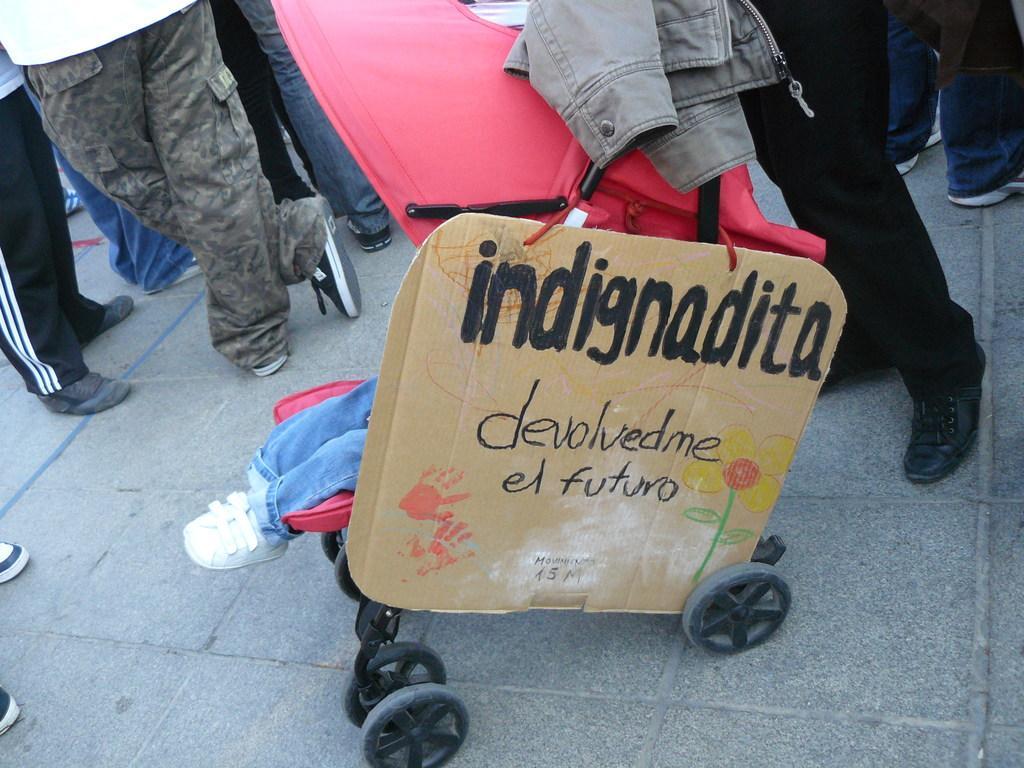In one or two sentences, can you explain what this image depicts? In this picture we can see board and cloth on a stroller. We can see legs of people on the ground. 